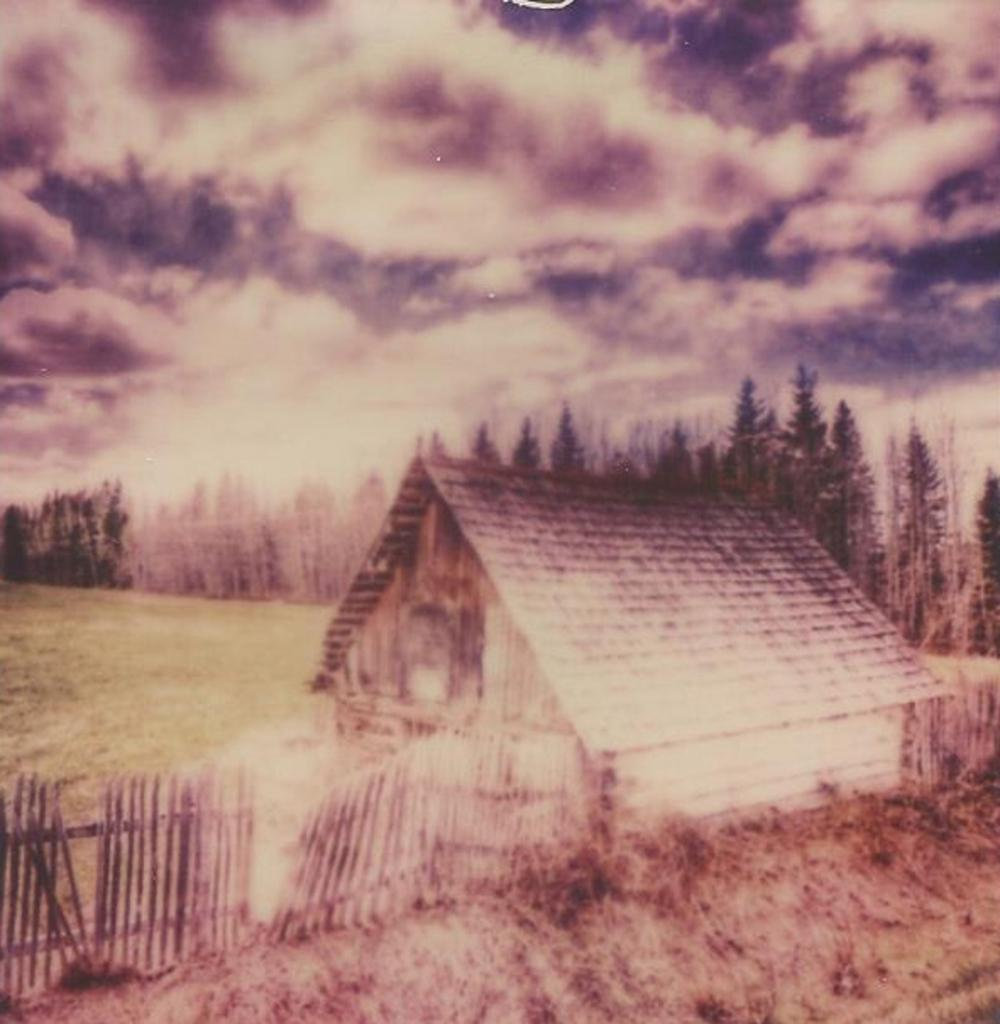What is depicted on the poster in the image? The poster contains a house. What type of vegetation can be seen in the image? There is grass and trees in the image. What architectural feature is present in the image? There is a fence in the image. What is visible in the background of the image? The sky is visible in the image, and clouds are present in the sky. Who is the creator of the wing depicted in the image? There is no wing depicted in the image. How does the grass provide comfort in the image? The grass does not provide comfort in the image; it is simply a part of the landscape. 